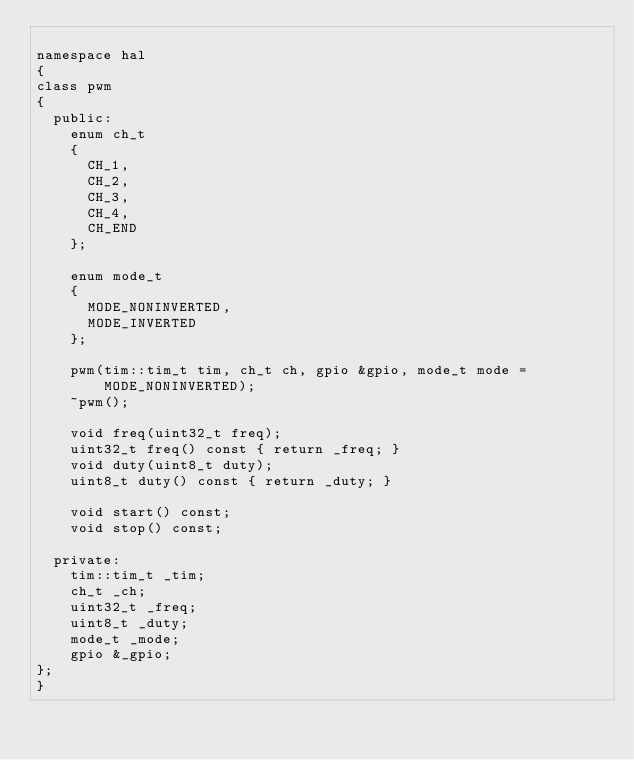<code> <loc_0><loc_0><loc_500><loc_500><_C++_>
namespace hal
{
class pwm
{
	public:
		enum ch_t
		{
			CH_1,
			CH_2,
			CH_3,
			CH_4,
			CH_END
		};
		
		enum mode_t
		{
			MODE_NONINVERTED,
			MODE_INVERTED
		};
		
		pwm(tim::tim_t tim, ch_t ch, gpio &gpio, mode_t mode = MODE_NONINVERTED);
		~pwm();
		
		void freq(uint32_t freq);
		uint32_t freq() const { return _freq; }
		void duty(uint8_t duty);
		uint8_t duty() const { return _duty; }
		
		void start() const;
		void stop() const;
	
	private:
		tim::tim_t _tim;
		ch_t _ch;
		uint32_t _freq;
		uint8_t _duty;
		mode_t _mode;
		gpio &_gpio;
};
}
</code> 